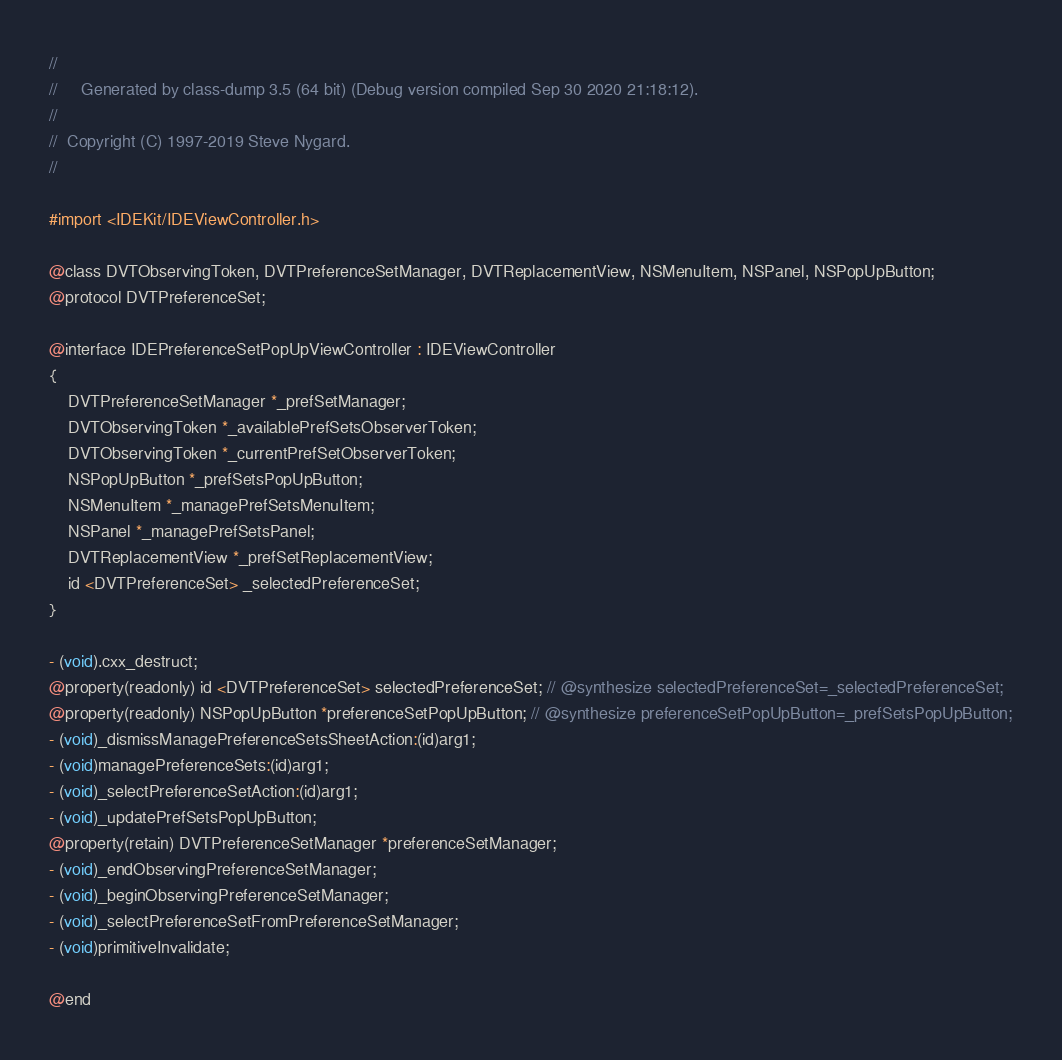<code> <loc_0><loc_0><loc_500><loc_500><_C_>//
//     Generated by class-dump 3.5 (64 bit) (Debug version compiled Sep 30 2020 21:18:12).
//
//  Copyright (C) 1997-2019 Steve Nygard.
//

#import <IDEKit/IDEViewController.h>

@class DVTObservingToken, DVTPreferenceSetManager, DVTReplacementView, NSMenuItem, NSPanel, NSPopUpButton;
@protocol DVTPreferenceSet;

@interface IDEPreferenceSetPopUpViewController : IDEViewController
{
    DVTPreferenceSetManager *_prefSetManager;
    DVTObservingToken *_availablePrefSetsObserverToken;
    DVTObservingToken *_currentPrefSetObserverToken;
    NSPopUpButton *_prefSetsPopUpButton;
    NSMenuItem *_managePrefSetsMenuItem;
    NSPanel *_managePrefSetsPanel;
    DVTReplacementView *_prefSetReplacementView;
    id <DVTPreferenceSet> _selectedPreferenceSet;
}

- (void).cxx_destruct;
@property(readonly) id <DVTPreferenceSet> selectedPreferenceSet; // @synthesize selectedPreferenceSet=_selectedPreferenceSet;
@property(readonly) NSPopUpButton *preferenceSetPopUpButton; // @synthesize preferenceSetPopUpButton=_prefSetsPopUpButton;
- (void)_dismissManagePreferenceSetsSheetAction:(id)arg1;
- (void)managePreferenceSets:(id)arg1;
- (void)_selectPreferenceSetAction:(id)arg1;
- (void)_updatePrefSetsPopUpButton;
@property(retain) DVTPreferenceSetManager *preferenceSetManager;
- (void)_endObservingPreferenceSetManager;
- (void)_beginObservingPreferenceSetManager;
- (void)_selectPreferenceSetFromPreferenceSetManager;
- (void)primitiveInvalidate;

@end

</code> 